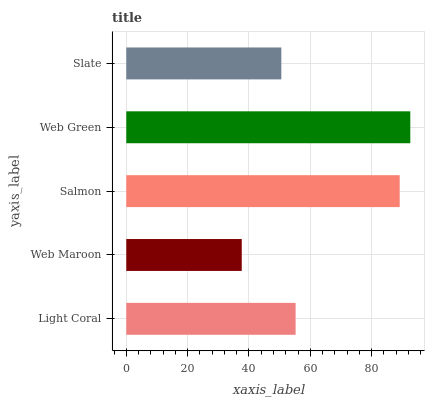Is Web Maroon the minimum?
Answer yes or no. Yes. Is Web Green the maximum?
Answer yes or no. Yes. Is Salmon the minimum?
Answer yes or no. No. Is Salmon the maximum?
Answer yes or no. No. Is Salmon greater than Web Maroon?
Answer yes or no. Yes. Is Web Maroon less than Salmon?
Answer yes or no. Yes. Is Web Maroon greater than Salmon?
Answer yes or no. No. Is Salmon less than Web Maroon?
Answer yes or no. No. Is Light Coral the high median?
Answer yes or no. Yes. Is Light Coral the low median?
Answer yes or no. Yes. Is Slate the high median?
Answer yes or no. No. Is Salmon the low median?
Answer yes or no. No. 